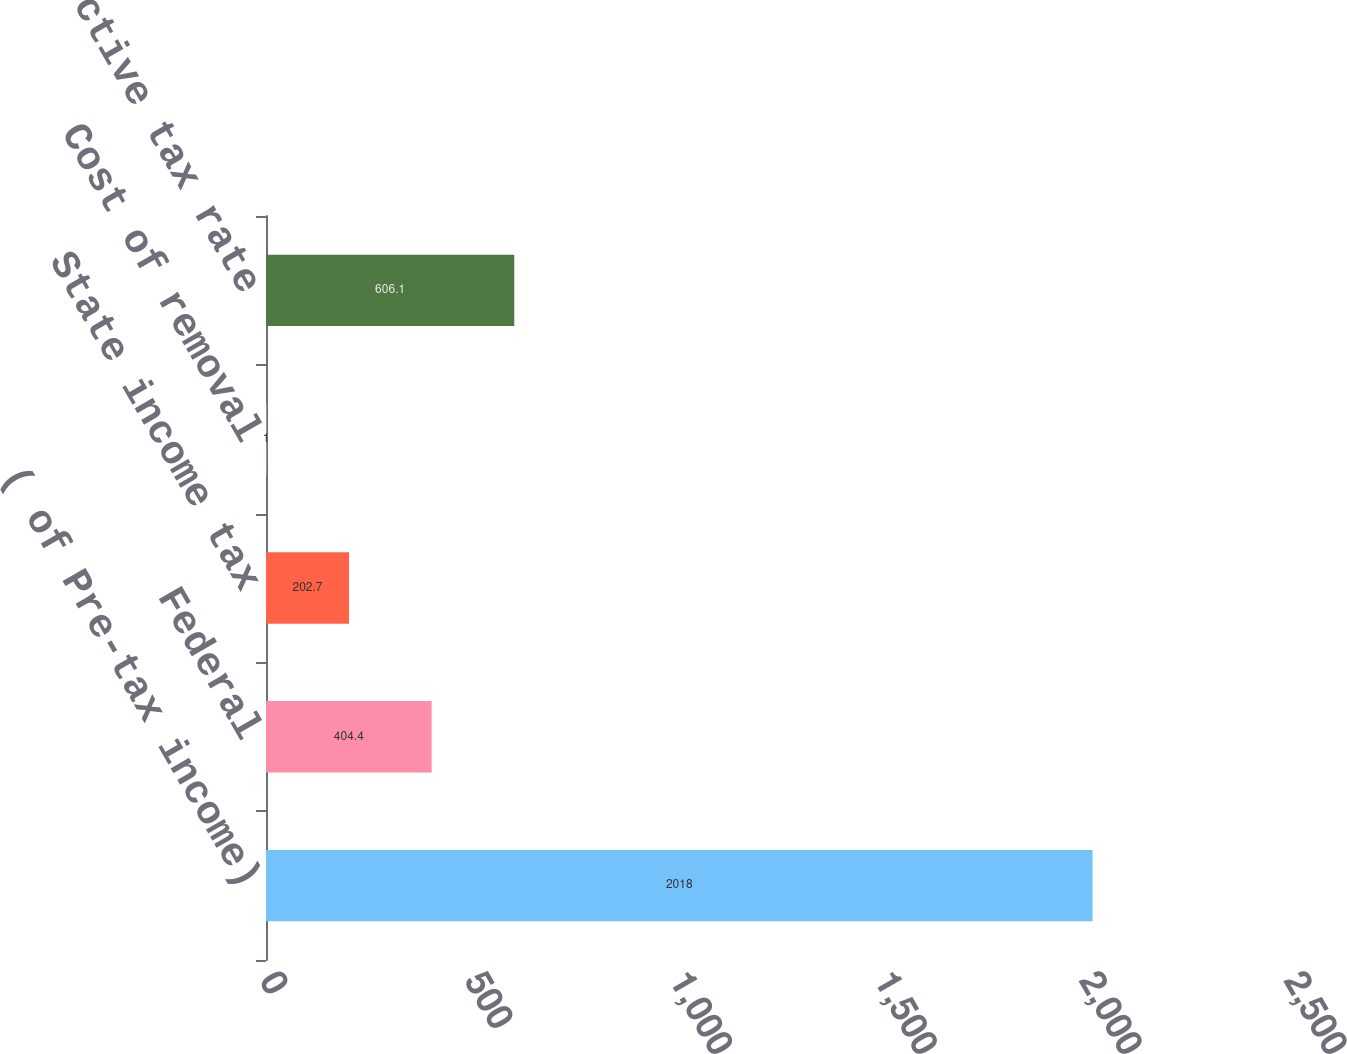Convert chart to OTSL. <chart><loc_0><loc_0><loc_500><loc_500><bar_chart><fcel>( of Pre-tax income)<fcel>Federal<fcel>State income tax<fcel>Cost of removal<fcel>Effective tax rate<nl><fcel>2018<fcel>404.4<fcel>202.7<fcel>1<fcel>606.1<nl></chart> 